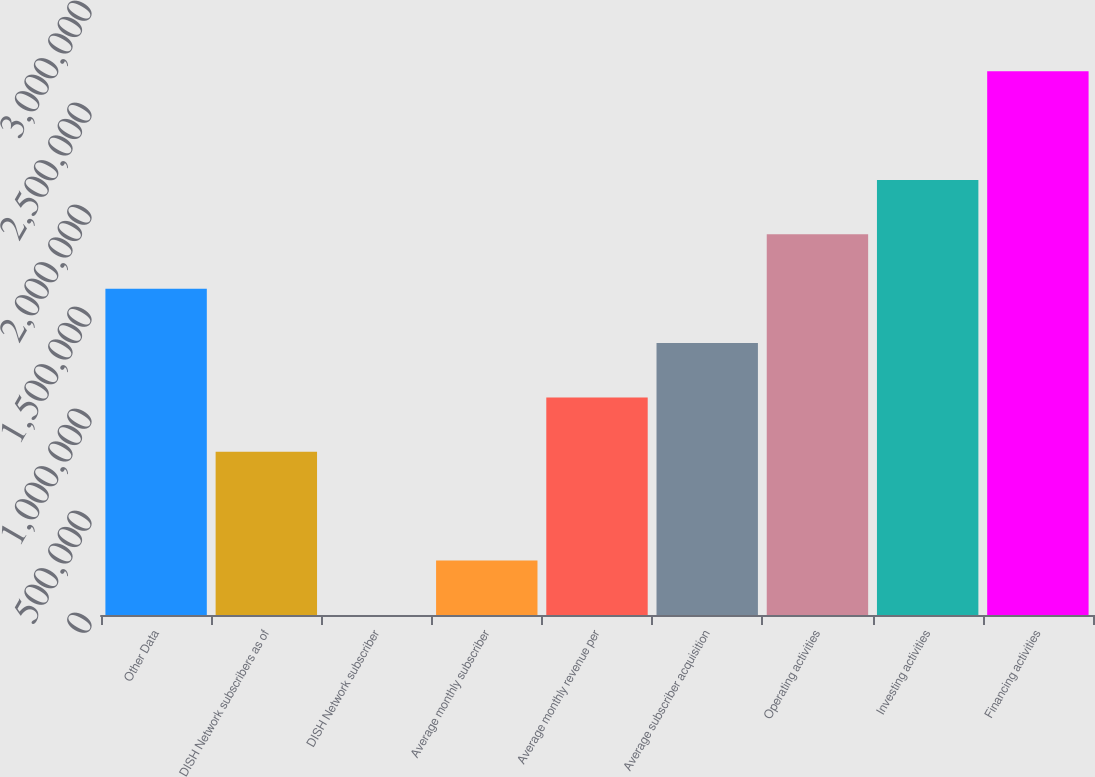Convert chart to OTSL. <chart><loc_0><loc_0><loc_500><loc_500><bar_chart><fcel>Other Data<fcel>DISH Network subscribers as of<fcel>DISH Network subscriber<fcel>Average monthly subscriber<fcel>Average monthly revenue per<fcel>Average subscriber acquisition<fcel>Operating activities<fcel>Investing activities<fcel>Financing activities<nl><fcel>1.59961e+06<fcel>799808<fcel>1.48<fcel>266604<fcel>1.06641e+06<fcel>1.33301e+06<fcel>1.86622e+06<fcel>2.13282e+06<fcel>2.66602e+06<nl></chart> 